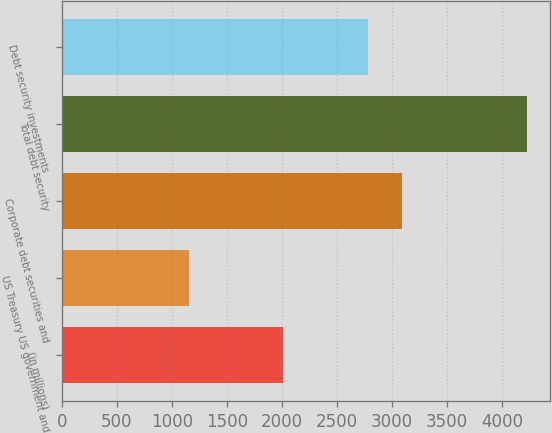Convert chart to OTSL. <chart><loc_0><loc_0><loc_500><loc_500><bar_chart><fcel>(in millions)<fcel>US Treasury US government and<fcel>Corporate debt securities and<fcel>Total debt security<fcel>Debt security investments<nl><fcel>2008<fcel>1159<fcel>3087.9<fcel>4228<fcel>2781<nl></chart> 